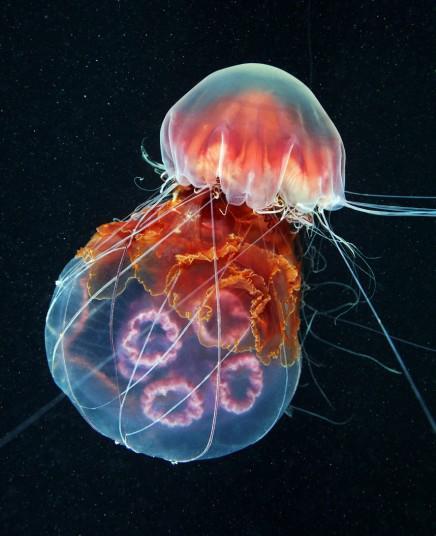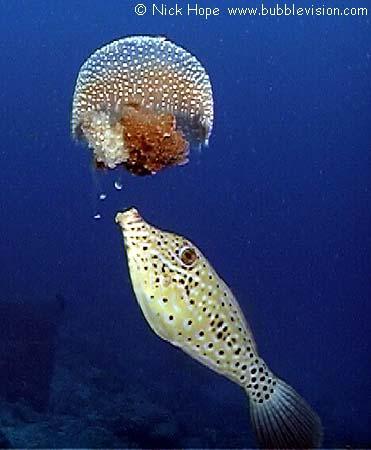The first image is the image on the left, the second image is the image on the right. Examine the images to the left and right. Is the description "There are multiple jellyfish in the image on the left." accurate? Answer yes or no. Yes. The first image is the image on the left, the second image is the image on the right. Analyze the images presented: Is the assertion "All jellyfish have translucent glowing bluish bodies, and all trail slender tendrils." valid? Answer yes or no. No. 